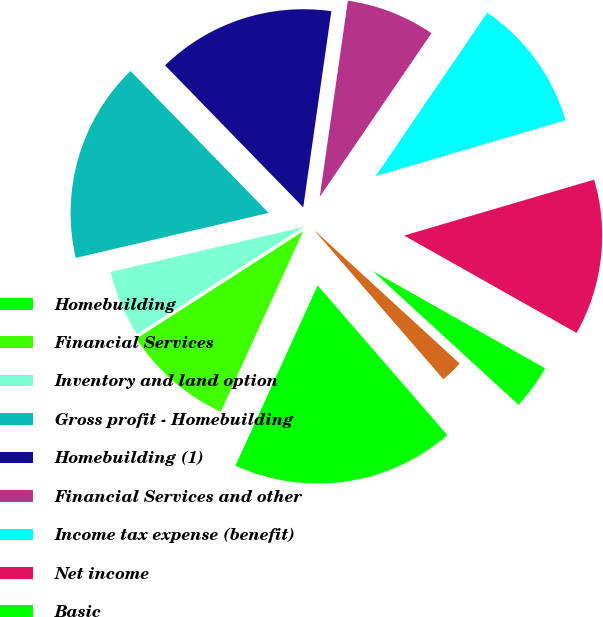<chart> <loc_0><loc_0><loc_500><loc_500><pie_chart><fcel>Homebuilding<fcel>Financial Services<fcel>Inventory and land option<fcel>Gross profit - Homebuilding<fcel>Homebuilding (1)<fcel>Financial Services and other<fcel>Income tax expense (benefit)<fcel>Net income<fcel>Basic<fcel>Diluted<nl><fcel>18.18%<fcel>9.09%<fcel>5.45%<fcel>16.36%<fcel>14.55%<fcel>7.27%<fcel>10.91%<fcel>12.73%<fcel>3.64%<fcel>1.82%<nl></chart> 